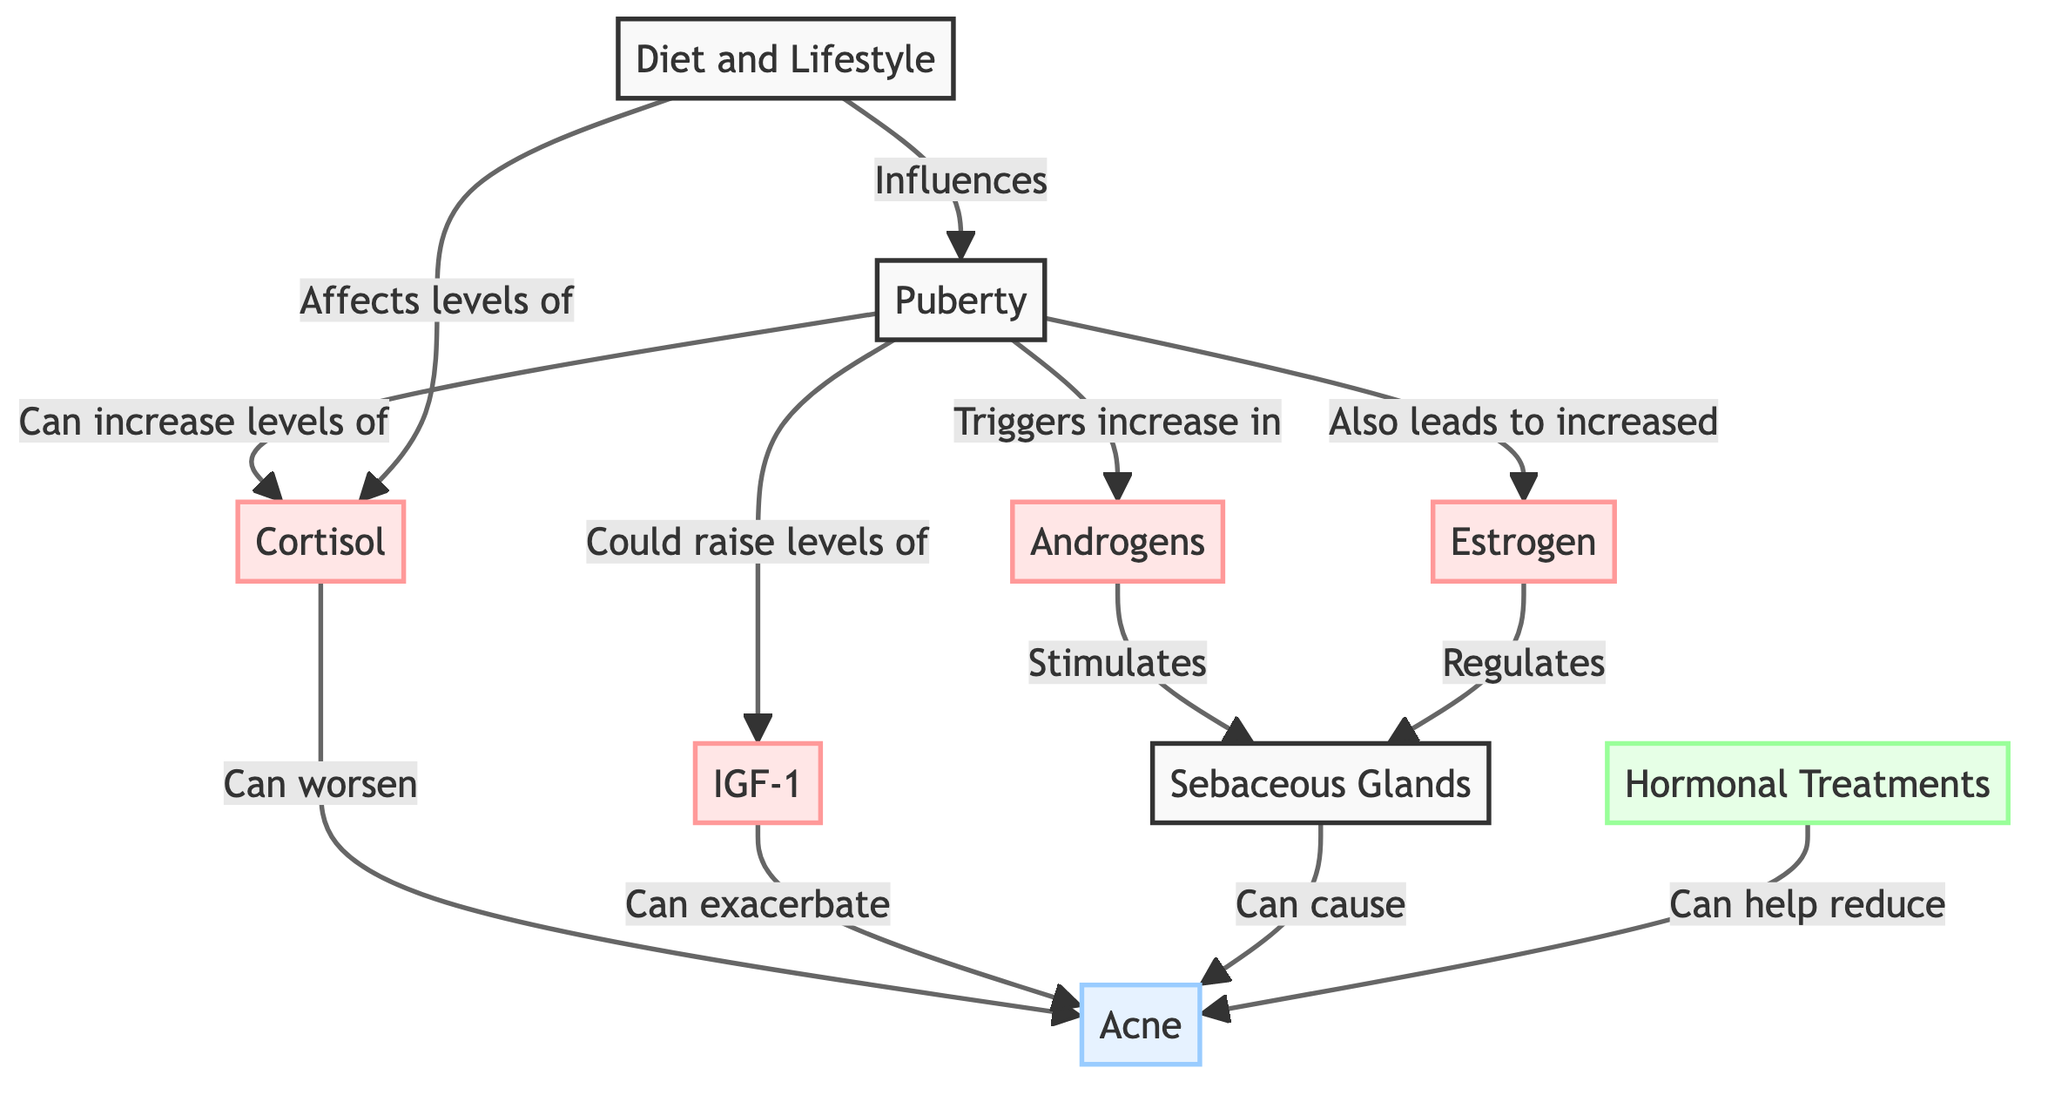What triggers the increase in androgens? The diagram indicates that puberty triggers the increase in androgens. This is shown by the arrow leading from puberty to androgens, indicating a direct relationship.
Answer: puberty What condition is worsened by cortisol? According to the diagram, cortisol can worsen acne, as indicated by the arrow leading from cortisol to acne.
Answer: acne How many hormones are represented in the diagram? The diagram displays four hormones: androgens, estrogen, cortisol, and IGF-1. By counting the labeled hormone nodes, we arrive at the total.
Answer: four What influence does diet and lifestyle have on hormonal levels? The diagram shows that diet and lifestyle can affect cortisol levels, as indicated by the arrow pointing from diet and lifestyle to cortisol.
Answer: affects Which hormone regulates sebaceous glands? The diagram shows that both androgens and estrogen can regulate sebaceous glands, as indicated by the arrows leading from both hormones to sebaceous glands.
Answer: estrogen Which treatment option is recommended to help reduce acne? According to the diagram, hormonal treatments are recommended to help reduce acne, indicated by the arrow from hormonal treatments to acne.
Answer: hormonal treatments Is IGF-1 associated with exacerbating acne? Yes, the diagram shows an arrow from IGF-1 to acne, indicating that IGF-1 can exacerbate acne.
Answer: yes What two factors influence the onset of puberty? The diagram indicates that both hormonal changes and diet and lifestyle influence the onset of puberty. This is inferred from the arrows connecting these two factors back to puberty.
Answer: hormonal changes and diet How does cortisol relate to the onset of acne? The diagram indicates that hormonal changes during puberty can increase cortisol levels, which can worsen acne. This relationship shows a flow from puberty to cortisol and then to acne.
Answer: worsens acne 